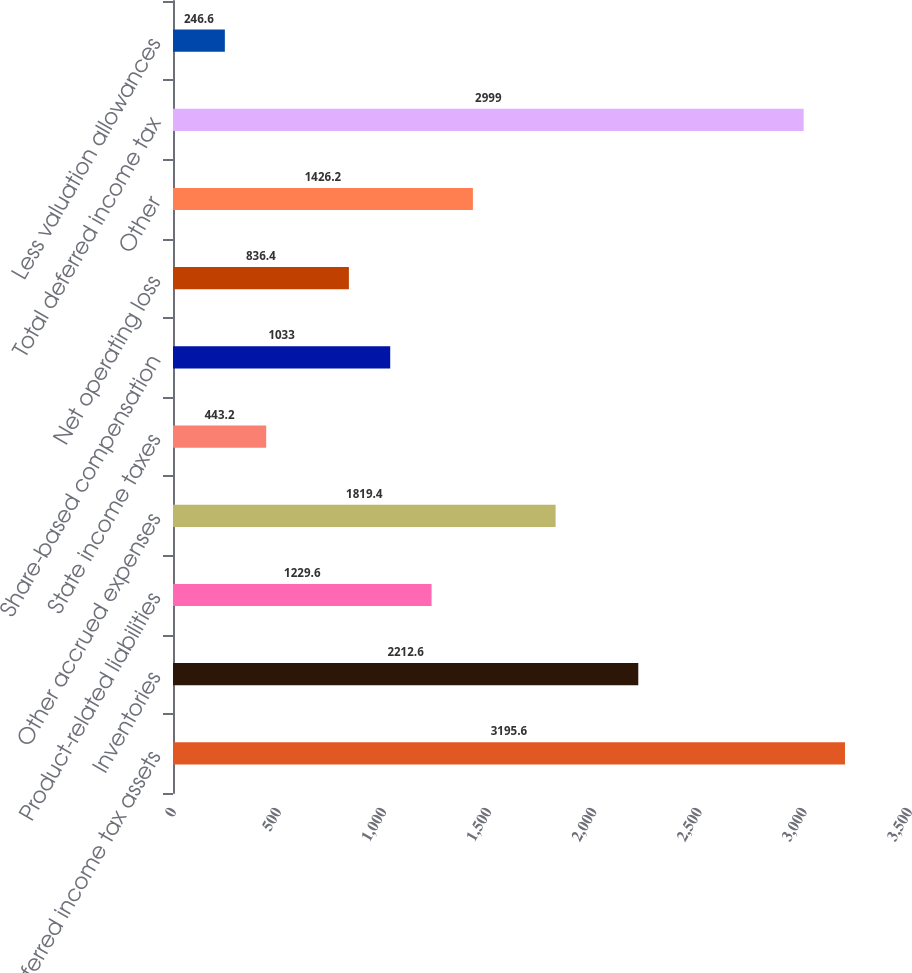Convert chart to OTSL. <chart><loc_0><loc_0><loc_500><loc_500><bar_chart><fcel>Deferred income tax assets<fcel>Inventories<fcel>Product-related liabilities<fcel>Other accrued expenses<fcel>State income taxes<fcel>Share-based compensation<fcel>Net operating loss<fcel>Other<fcel>Total deferred income tax<fcel>Less valuation allowances<nl><fcel>3195.6<fcel>2212.6<fcel>1229.6<fcel>1819.4<fcel>443.2<fcel>1033<fcel>836.4<fcel>1426.2<fcel>2999<fcel>246.6<nl></chart> 